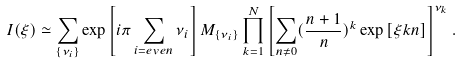<formula> <loc_0><loc_0><loc_500><loc_500>I ( \xi ) \simeq \sum _ { \{ \nu _ { i } \} } \exp \left [ i \pi \sum _ { i = e v e n } \nu _ { i } \right ] M _ { \{ \nu _ { i } \} } \prod _ { k = 1 } ^ { N } \left [ \sum _ { n \neq 0 } ( \frac { n + 1 } { n } ) ^ { k } \exp \left [ \xi k n \right ] \right ] ^ { \nu _ { k } } .</formula> 